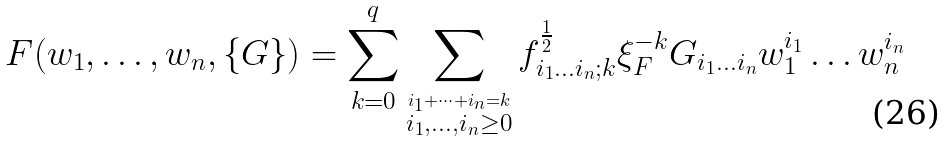Convert formula to latex. <formula><loc_0><loc_0><loc_500><loc_500>F ( w _ { 1 } , \dots , w _ { n } , \{ G \} ) = \sum _ { k = 0 } ^ { q } \sum _ { \stackrel { i _ { 1 } + \dots + i _ { n } = k } { i _ { 1 } , \dots , i _ { n } \geq 0 } } f _ { i _ { 1 } \dots i _ { n } ; k } ^ { \frac { 1 } { 2 } } \xi _ { F } ^ { - k } G _ { i _ { 1 } \dots i _ { n } } w _ { 1 } ^ { i _ { 1 } } \dots w _ { n } ^ { i _ { n } }</formula> 